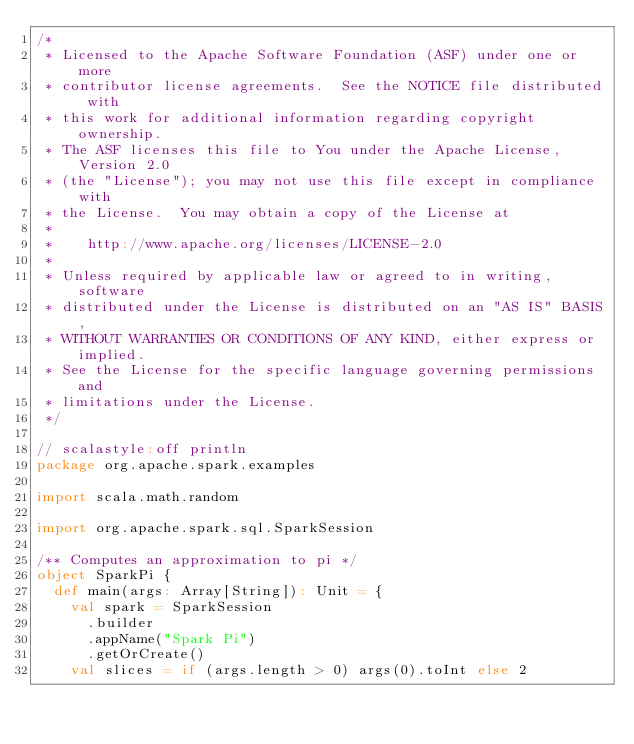Convert code to text. <code><loc_0><loc_0><loc_500><loc_500><_Scala_>/*
 * Licensed to the Apache Software Foundation (ASF) under one or more
 * contributor license agreements.  See the NOTICE file distributed with
 * this work for additional information regarding copyright ownership.
 * The ASF licenses this file to You under the Apache License, Version 2.0
 * (the "License"); you may not use this file except in compliance with
 * the License.  You may obtain a copy of the License at
 *
 *    http://www.apache.org/licenses/LICENSE-2.0
 *
 * Unless required by applicable law or agreed to in writing, software
 * distributed under the License is distributed on an "AS IS" BASIS,
 * WITHOUT WARRANTIES OR CONDITIONS OF ANY KIND, either express or implied.
 * See the License for the specific language governing permissions and
 * limitations under the License.
 */

// scalastyle:off println
package org.apache.spark.examples

import scala.math.random

import org.apache.spark.sql.SparkSession

/** Computes an approximation to pi */
object SparkPi {
  def main(args: Array[String]): Unit = {
    val spark = SparkSession
      .builder
      .appName("Spark Pi")
      .getOrCreate()
    val slices = if (args.length > 0) args(0).toInt else 2</code> 